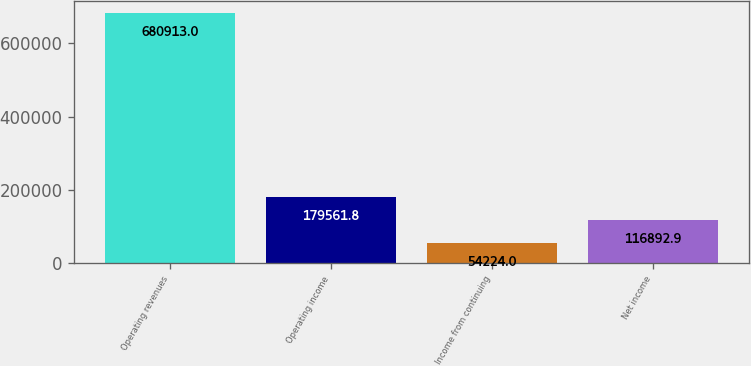Convert chart to OTSL. <chart><loc_0><loc_0><loc_500><loc_500><bar_chart><fcel>Operating revenues<fcel>Operating income<fcel>Income from continuing<fcel>Net income<nl><fcel>680913<fcel>179562<fcel>54224<fcel>116893<nl></chart> 